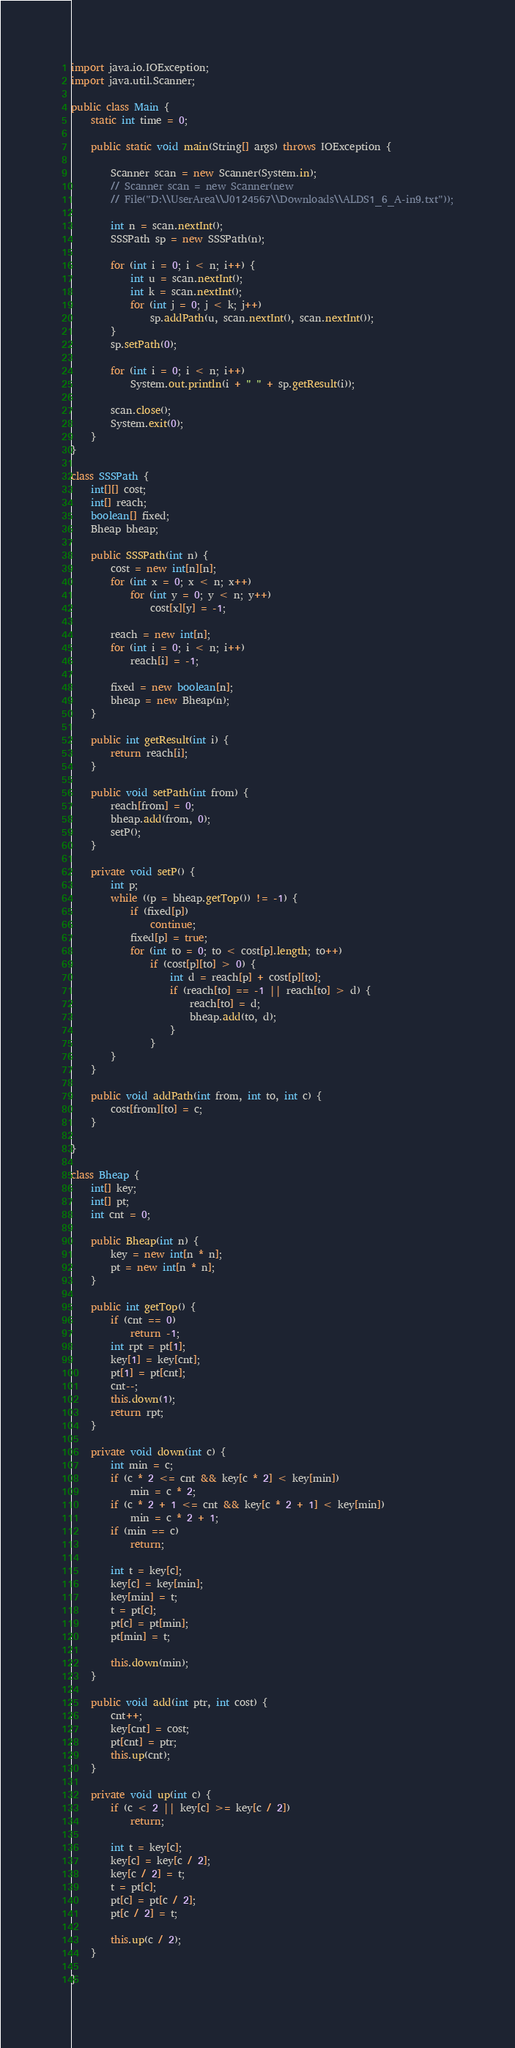Convert code to text. <code><loc_0><loc_0><loc_500><loc_500><_Java_>import java.io.IOException;
import java.util.Scanner;

public class Main {
	static int time = 0;

	public static void main(String[] args) throws IOException {

		Scanner scan = new Scanner(System.in);
		// Scanner scan = new Scanner(new
		// File("D:\\UserArea\\J0124567\\Downloads\\ALDS1_6_A-in9.txt"));

		int n = scan.nextInt();
		SSSPath sp = new SSSPath(n);

		for (int i = 0; i < n; i++) {
			int u = scan.nextInt();
			int k = scan.nextInt();
			for (int j = 0; j < k; j++)
				sp.addPath(u, scan.nextInt(), scan.nextInt());
		}
		sp.setPath(0);

		for (int i = 0; i < n; i++)
			System.out.println(i + " " + sp.getResult(i));

		scan.close();
		System.exit(0);
	}
}

class SSSPath {
	int[][] cost;
	int[] reach;
	boolean[] fixed;
	Bheap bheap;

	public SSSPath(int n) {
		cost = new int[n][n];
		for (int x = 0; x < n; x++)
			for (int y = 0; y < n; y++)
				cost[x][y] = -1;

		reach = new int[n];
		for (int i = 0; i < n; i++)
			reach[i] = -1;

		fixed = new boolean[n];
		bheap = new Bheap(n);
	}

	public int getResult(int i) {
		return reach[i];
	}

	public void setPath(int from) {
		reach[from] = 0;
		bheap.add(from, 0);
		setP();
	}

	private void setP() {
		int p;
		while ((p = bheap.getTop()) != -1) {
			if (fixed[p])
				continue;
			fixed[p] = true;
			for (int to = 0; to < cost[p].length; to++)
				if (cost[p][to] > 0) {
					int d = reach[p] + cost[p][to];
					if (reach[to] == -1 || reach[to] > d) {
						reach[to] = d;
						bheap.add(to, d);
					}
				}
		}
	}

	public void addPath(int from, int to, int c) {
		cost[from][to] = c;
	}

}

class Bheap {
	int[] key;
	int[] pt;
	int cnt = 0;

	public Bheap(int n) {
		key = new int[n * n];
		pt = new int[n * n];
	}

	public int getTop() {
		if (cnt == 0)
			return -1;
		int rpt = pt[1];
		key[1] = key[cnt];
		pt[1] = pt[cnt];
		cnt--;
		this.down(1);
		return rpt;
	}

	private void down(int c) {
		int min = c;
		if (c * 2 <= cnt && key[c * 2] < key[min])
			min = c * 2;
		if (c * 2 + 1 <= cnt && key[c * 2 + 1] < key[min])
			min = c * 2 + 1;
		if (min == c)
			return;

		int t = key[c];
		key[c] = key[min];
		key[min] = t;
		t = pt[c];
		pt[c] = pt[min];
		pt[min] = t;

		this.down(min);
	}

	public void add(int ptr, int cost) {
		cnt++;
		key[cnt] = cost;
		pt[cnt] = ptr;
		this.up(cnt);
	}

	private void up(int c) {
		if (c < 2 || key[c] >= key[c / 2])
			return;

		int t = key[c];
		key[c] = key[c / 2];
		key[c / 2] = t;
		t = pt[c];
		pt[c] = pt[c / 2];
		pt[c / 2] = t;

		this.up(c / 2);
	}

}</code> 